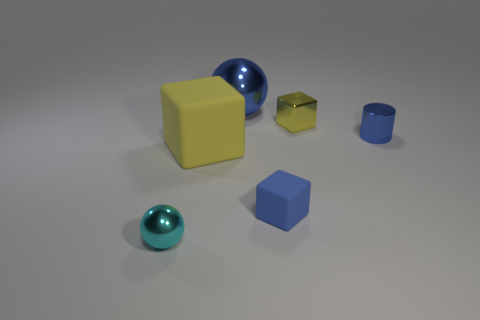Add 3 blue metallic spheres. How many objects exist? 9 Subtract all cylinders. How many objects are left? 5 Subtract all big brown objects. Subtract all blue rubber cubes. How many objects are left? 5 Add 3 blue metal things. How many blue metal things are left? 5 Add 4 blue matte cubes. How many blue matte cubes exist? 5 Subtract 0 red balls. How many objects are left? 6 